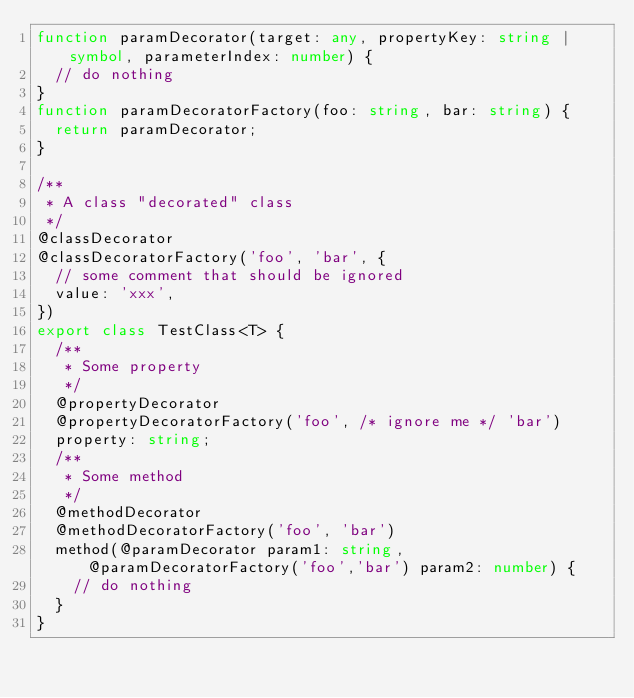<code> <loc_0><loc_0><loc_500><loc_500><_TypeScript_>function paramDecorator(target: any, propertyKey: string | symbol, parameterIndex: number) {
  // do nothing
}
function paramDecoratorFactory(foo: string, bar: string) {
  return paramDecorator;
}

/**
 * A class "decorated" class
 */
@classDecorator
@classDecoratorFactory('foo', 'bar', {
  // some comment that should be ignored
  value: 'xxx',
})
export class TestClass<T> {
  /**
   * Some property
   */
  @propertyDecorator
  @propertyDecoratorFactory('foo', /* ignore me */ 'bar')
  property: string;
  /**
   * Some method
   */
  @methodDecorator
  @methodDecoratorFactory('foo', 'bar')
  method(@paramDecorator param1: string, @paramDecoratorFactory('foo','bar') param2: number) {
    // do nothing
  }
}
</code> 